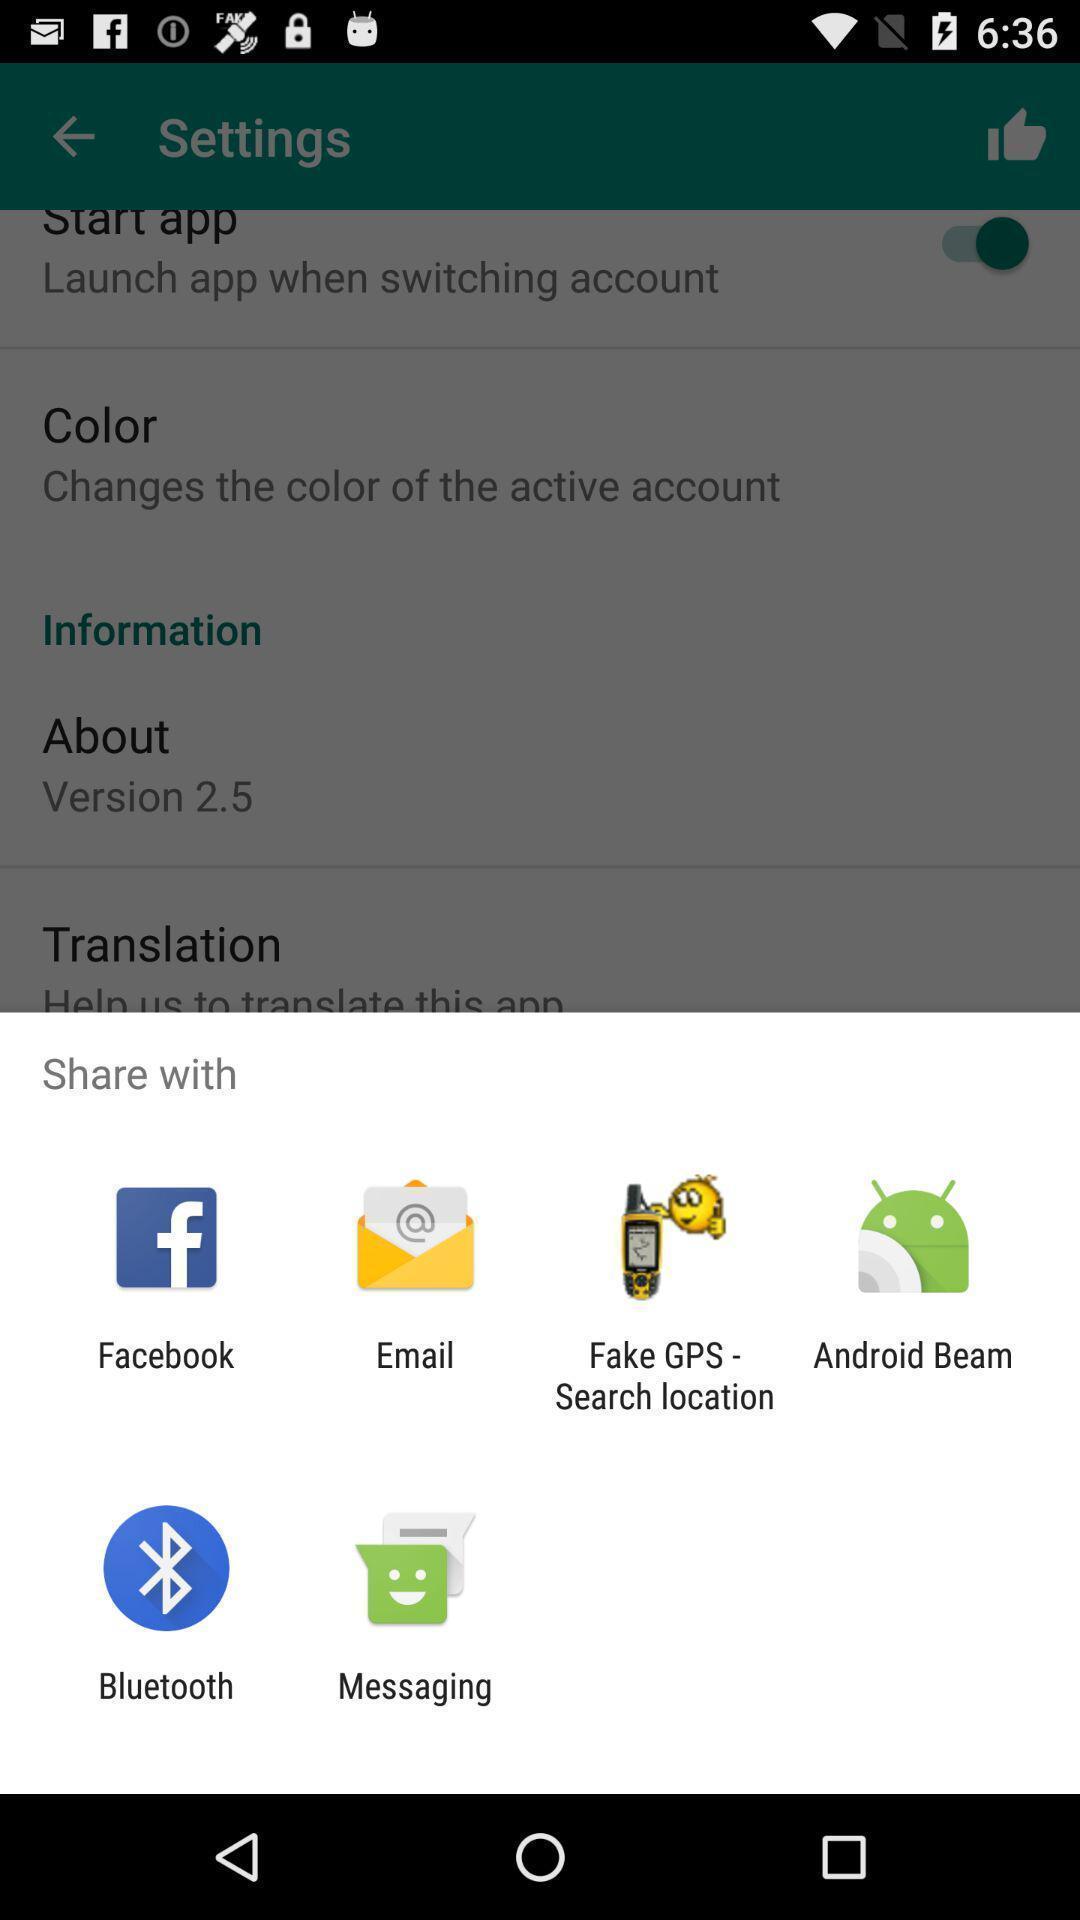Provide a description of this screenshot. Pop-up shows to share with multiple apps. 